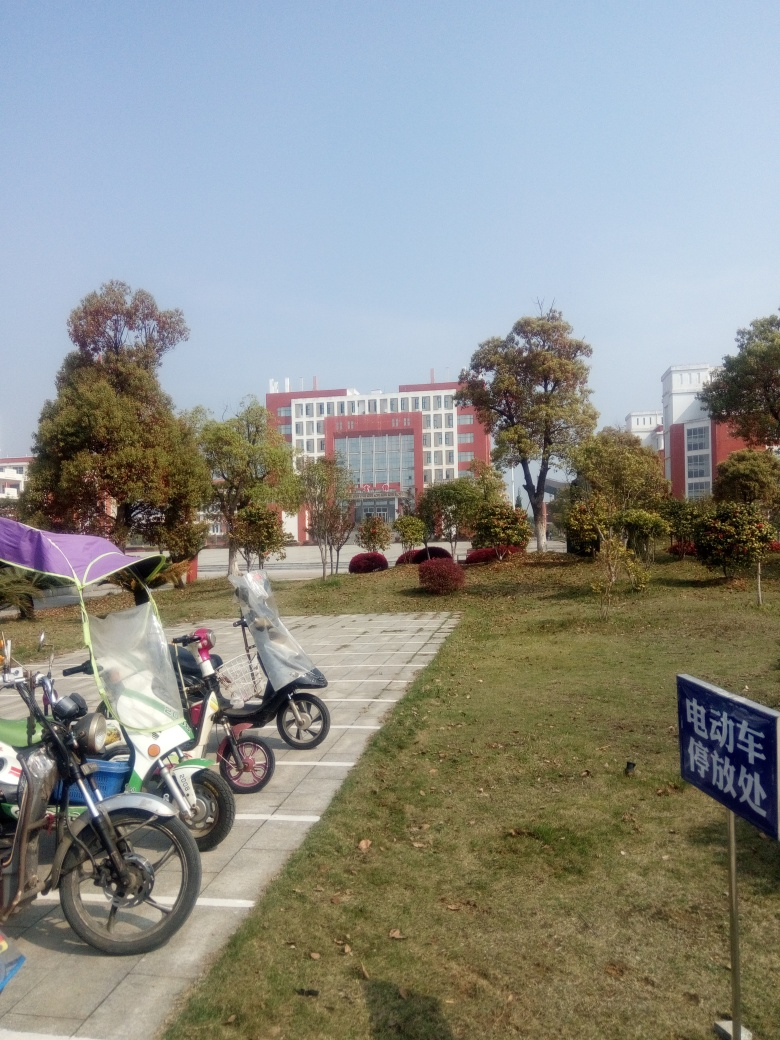What is the quality of this picture? The quality of the picture is moderate. It appears to be taken during the day under natural light, which provides good visibility. However, the image is not very sharp, and there's room for better composition. The resolution could also be higher to capture more detail. 